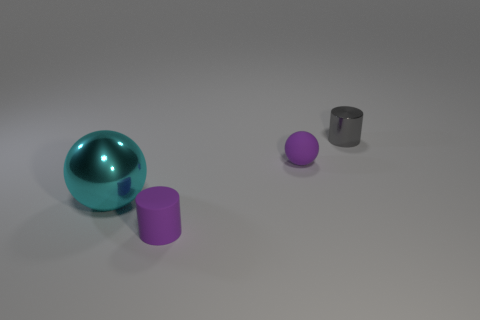Is there anything else that is the same size as the metallic sphere?
Offer a terse response. No. There is a small object that is behind the big cyan shiny sphere and in front of the metal cylinder; what is its shape?
Provide a short and direct response. Sphere. There is a purple matte object that is the same shape as the small gray object; what is its size?
Give a very brief answer. Small. What number of small objects have the same material as the large thing?
Provide a succinct answer. 1. Is the color of the rubber cylinder the same as the sphere right of the large cyan sphere?
Offer a terse response. Yes. Are there more blue metal blocks than gray things?
Offer a terse response. No. The matte cylinder is what color?
Provide a succinct answer. Purple. Is the color of the tiny object that is in front of the big cyan metallic sphere the same as the tiny ball?
Your answer should be compact. Yes. What material is the tiny sphere that is the same color as the small rubber cylinder?
Give a very brief answer. Rubber. How many large balls are the same color as the metallic cylinder?
Offer a terse response. 0. 